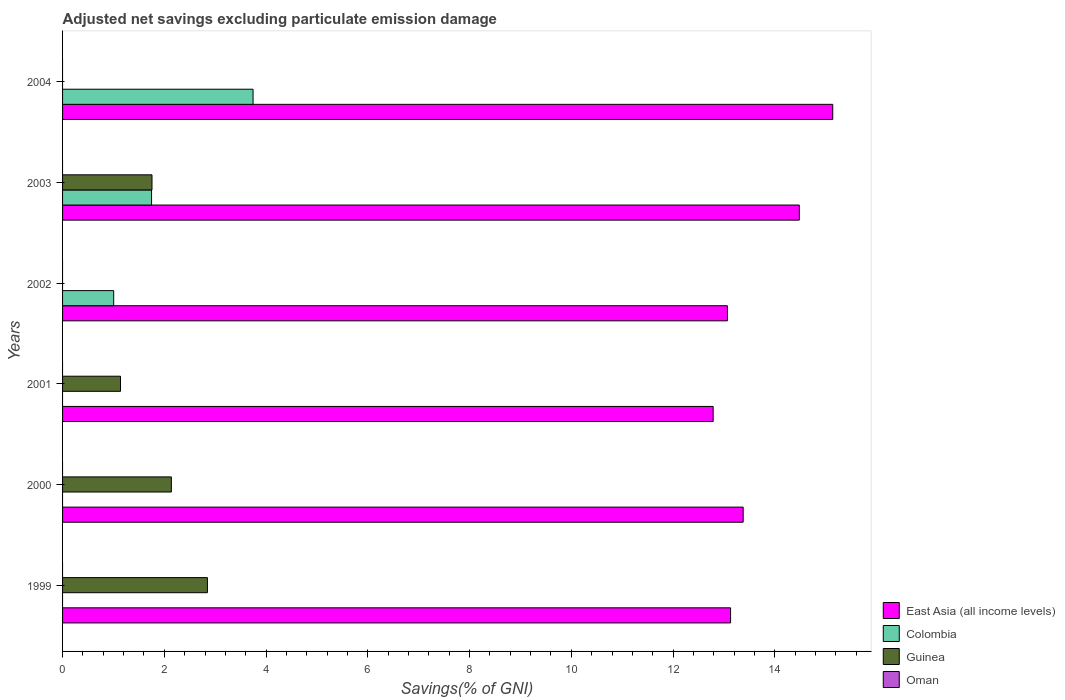Are the number of bars on each tick of the Y-axis equal?
Provide a succinct answer. No. How many bars are there on the 2nd tick from the bottom?
Your answer should be compact. 2. What is the label of the 6th group of bars from the top?
Your answer should be compact. 1999. Across all years, what is the maximum adjusted net savings in East Asia (all income levels)?
Ensure brevity in your answer.  15.14. Across all years, what is the minimum adjusted net savings in East Asia (all income levels)?
Your answer should be compact. 12.79. In which year was the adjusted net savings in East Asia (all income levels) maximum?
Provide a short and direct response. 2004. What is the total adjusted net savings in East Asia (all income levels) in the graph?
Ensure brevity in your answer.  81.98. What is the difference between the adjusted net savings in East Asia (all income levels) in 2001 and that in 2003?
Make the answer very short. -1.69. What is the difference between the adjusted net savings in East Asia (all income levels) in 2003 and the adjusted net savings in Colombia in 2002?
Offer a very short reply. 13.48. What is the average adjusted net savings in East Asia (all income levels) per year?
Offer a very short reply. 13.66. In the year 2000, what is the difference between the adjusted net savings in East Asia (all income levels) and adjusted net savings in Guinea?
Your answer should be very brief. 11.24. In how many years, is the adjusted net savings in Oman greater than 4.8 %?
Your answer should be very brief. 0. What is the ratio of the adjusted net savings in Guinea in 2001 to that in 2003?
Make the answer very short. 0.65. Is the adjusted net savings in Guinea in 1999 less than that in 2000?
Your answer should be very brief. No. What is the difference between the highest and the second highest adjusted net savings in Colombia?
Offer a very short reply. 2. What is the difference between the highest and the lowest adjusted net savings in Guinea?
Provide a short and direct response. 2.85. Are all the bars in the graph horizontal?
Ensure brevity in your answer.  Yes. How many years are there in the graph?
Offer a terse response. 6. Are the values on the major ticks of X-axis written in scientific E-notation?
Keep it short and to the point. No. Does the graph contain grids?
Offer a terse response. No. Where does the legend appear in the graph?
Provide a succinct answer. Bottom right. How many legend labels are there?
Your response must be concise. 4. What is the title of the graph?
Make the answer very short. Adjusted net savings excluding particulate emission damage. Does "Guam" appear as one of the legend labels in the graph?
Give a very brief answer. No. What is the label or title of the X-axis?
Your answer should be compact. Savings(% of GNI). What is the label or title of the Y-axis?
Ensure brevity in your answer.  Years. What is the Savings(% of GNI) of East Asia (all income levels) in 1999?
Offer a terse response. 13.13. What is the Savings(% of GNI) of Guinea in 1999?
Provide a short and direct response. 2.85. What is the Savings(% of GNI) of East Asia (all income levels) in 2000?
Your answer should be very brief. 13.38. What is the Savings(% of GNI) in Guinea in 2000?
Provide a succinct answer. 2.14. What is the Savings(% of GNI) in East Asia (all income levels) in 2001?
Provide a succinct answer. 12.79. What is the Savings(% of GNI) of Colombia in 2001?
Your answer should be very brief. 0. What is the Savings(% of GNI) of Guinea in 2001?
Your answer should be very brief. 1.14. What is the Savings(% of GNI) in East Asia (all income levels) in 2002?
Give a very brief answer. 13.07. What is the Savings(% of GNI) of Colombia in 2002?
Give a very brief answer. 1. What is the Savings(% of GNI) of Guinea in 2002?
Make the answer very short. 0. What is the Savings(% of GNI) of East Asia (all income levels) in 2003?
Provide a succinct answer. 14.48. What is the Savings(% of GNI) of Colombia in 2003?
Provide a short and direct response. 1.75. What is the Savings(% of GNI) of Guinea in 2003?
Ensure brevity in your answer.  1.76. What is the Savings(% of GNI) in East Asia (all income levels) in 2004?
Your answer should be very brief. 15.14. What is the Savings(% of GNI) of Colombia in 2004?
Provide a short and direct response. 3.74. Across all years, what is the maximum Savings(% of GNI) in East Asia (all income levels)?
Offer a very short reply. 15.14. Across all years, what is the maximum Savings(% of GNI) of Colombia?
Keep it short and to the point. 3.74. Across all years, what is the maximum Savings(% of GNI) of Guinea?
Make the answer very short. 2.85. Across all years, what is the minimum Savings(% of GNI) of East Asia (all income levels)?
Provide a succinct answer. 12.79. What is the total Savings(% of GNI) in East Asia (all income levels) in the graph?
Your response must be concise. 81.98. What is the total Savings(% of GNI) of Colombia in the graph?
Your answer should be compact. 6.5. What is the total Savings(% of GNI) in Guinea in the graph?
Give a very brief answer. 7.88. What is the total Savings(% of GNI) in Oman in the graph?
Make the answer very short. 0. What is the difference between the Savings(% of GNI) of East Asia (all income levels) in 1999 and that in 2000?
Keep it short and to the point. -0.25. What is the difference between the Savings(% of GNI) of Guinea in 1999 and that in 2000?
Ensure brevity in your answer.  0.71. What is the difference between the Savings(% of GNI) of East Asia (all income levels) in 1999 and that in 2001?
Give a very brief answer. 0.34. What is the difference between the Savings(% of GNI) in Guinea in 1999 and that in 2001?
Give a very brief answer. 1.71. What is the difference between the Savings(% of GNI) in East Asia (all income levels) in 1999 and that in 2002?
Provide a short and direct response. 0.06. What is the difference between the Savings(% of GNI) of East Asia (all income levels) in 1999 and that in 2003?
Your answer should be very brief. -1.35. What is the difference between the Savings(% of GNI) of Guinea in 1999 and that in 2003?
Keep it short and to the point. 1.09. What is the difference between the Savings(% of GNI) of East Asia (all income levels) in 1999 and that in 2004?
Provide a succinct answer. -2.01. What is the difference between the Savings(% of GNI) in East Asia (all income levels) in 2000 and that in 2001?
Your response must be concise. 0.59. What is the difference between the Savings(% of GNI) in East Asia (all income levels) in 2000 and that in 2002?
Ensure brevity in your answer.  0.31. What is the difference between the Savings(% of GNI) in East Asia (all income levels) in 2000 and that in 2003?
Provide a succinct answer. -1.1. What is the difference between the Savings(% of GNI) in Guinea in 2000 and that in 2003?
Your response must be concise. 0.38. What is the difference between the Savings(% of GNI) in East Asia (all income levels) in 2000 and that in 2004?
Give a very brief answer. -1.76. What is the difference between the Savings(% of GNI) in East Asia (all income levels) in 2001 and that in 2002?
Offer a terse response. -0.28. What is the difference between the Savings(% of GNI) of East Asia (all income levels) in 2001 and that in 2003?
Give a very brief answer. -1.69. What is the difference between the Savings(% of GNI) of Guinea in 2001 and that in 2003?
Ensure brevity in your answer.  -0.62. What is the difference between the Savings(% of GNI) of East Asia (all income levels) in 2001 and that in 2004?
Your answer should be compact. -2.35. What is the difference between the Savings(% of GNI) of East Asia (all income levels) in 2002 and that in 2003?
Offer a very short reply. -1.41. What is the difference between the Savings(% of GNI) in Colombia in 2002 and that in 2003?
Provide a succinct answer. -0.74. What is the difference between the Savings(% of GNI) in East Asia (all income levels) in 2002 and that in 2004?
Give a very brief answer. -2.07. What is the difference between the Savings(% of GNI) of Colombia in 2002 and that in 2004?
Your answer should be very brief. -2.74. What is the difference between the Savings(% of GNI) in East Asia (all income levels) in 2003 and that in 2004?
Make the answer very short. -0.66. What is the difference between the Savings(% of GNI) of Colombia in 2003 and that in 2004?
Offer a very short reply. -2. What is the difference between the Savings(% of GNI) of East Asia (all income levels) in 1999 and the Savings(% of GNI) of Guinea in 2000?
Keep it short and to the point. 10.99. What is the difference between the Savings(% of GNI) in East Asia (all income levels) in 1999 and the Savings(% of GNI) in Guinea in 2001?
Your answer should be compact. 11.99. What is the difference between the Savings(% of GNI) of East Asia (all income levels) in 1999 and the Savings(% of GNI) of Colombia in 2002?
Offer a very short reply. 12.13. What is the difference between the Savings(% of GNI) of East Asia (all income levels) in 1999 and the Savings(% of GNI) of Colombia in 2003?
Provide a succinct answer. 11.38. What is the difference between the Savings(% of GNI) of East Asia (all income levels) in 1999 and the Savings(% of GNI) of Guinea in 2003?
Give a very brief answer. 11.37. What is the difference between the Savings(% of GNI) in East Asia (all income levels) in 1999 and the Savings(% of GNI) in Colombia in 2004?
Make the answer very short. 9.39. What is the difference between the Savings(% of GNI) of East Asia (all income levels) in 2000 and the Savings(% of GNI) of Guinea in 2001?
Give a very brief answer. 12.24. What is the difference between the Savings(% of GNI) in East Asia (all income levels) in 2000 and the Savings(% of GNI) in Colombia in 2002?
Give a very brief answer. 12.37. What is the difference between the Savings(% of GNI) of East Asia (all income levels) in 2000 and the Savings(% of GNI) of Colombia in 2003?
Your answer should be very brief. 11.63. What is the difference between the Savings(% of GNI) in East Asia (all income levels) in 2000 and the Savings(% of GNI) in Guinea in 2003?
Provide a short and direct response. 11.62. What is the difference between the Savings(% of GNI) in East Asia (all income levels) in 2000 and the Savings(% of GNI) in Colombia in 2004?
Make the answer very short. 9.63. What is the difference between the Savings(% of GNI) in East Asia (all income levels) in 2001 and the Savings(% of GNI) in Colombia in 2002?
Offer a very short reply. 11.78. What is the difference between the Savings(% of GNI) of East Asia (all income levels) in 2001 and the Savings(% of GNI) of Colombia in 2003?
Provide a succinct answer. 11.04. What is the difference between the Savings(% of GNI) in East Asia (all income levels) in 2001 and the Savings(% of GNI) in Guinea in 2003?
Make the answer very short. 11.03. What is the difference between the Savings(% of GNI) in East Asia (all income levels) in 2001 and the Savings(% of GNI) in Colombia in 2004?
Your response must be concise. 9.04. What is the difference between the Savings(% of GNI) of East Asia (all income levels) in 2002 and the Savings(% of GNI) of Colombia in 2003?
Your answer should be compact. 11.32. What is the difference between the Savings(% of GNI) of East Asia (all income levels) in 2002 and the Savings(% of GNI) of Guinea in 2003?
Your answer should be compact. 11.31. What is the difference between the Savings(% of GNI) of Colombia in 2002 and the Savings(% of GNI) of Guinea in 2003?
Give a very brief answer. -0.75. What is the difference between the Savings(% of GNI) of East Asia (all income levels) in 2002 and the Savings(% of GNI) of Colombia in 2004?
Offer a terse response. 9.32. What is the difference between the Savings(% of GNI) in East Asia (all income levels) in 2003 and the Savings(% of GNI) in Colombia in 2004?
Your answer should be compact. 10.74. What is the average Savings(% of GNI) in East Asia (all income levels) per year?
Give a very brief answer. 13.66. What is the average Savings(% of GNI) in Colombia per year?
Give a very brief answer. 1.08. What is the average Savings(% of GNI) in Guinea per year?
Give a very brief answer. 1.31. In the year 1999, what is the difference between the Savings(% of GNI) of East Asia (all income levels) and Savings(% of GNI) of Guinea?
Provide a short and direct response. 10.28. In the year 2000, what is the difference between the Savings(% of GNI) of East Asia (all income levels) and Savings(% of GNI) of Guinea?
Your response must be concise. 11.24. In the year 2001, what is the difference between the Savings(% of GNI) of East Asia (all income levels) and Savings(% of GNI) of Guinea?
Ensure brevity in your answer.  11.65. In the year 2002, what is the difference between the Savings(% of GNI) in East Asia (all income levels) and Savings(% of GNI) in Colombia?
Keep it short and to the point. 12.06. In the year 2003, what is the difference between the Savings(% of GNI) of East Asia (all income levels) and Savings(% of GNI) of Colombia?
Provide a succinct answer. 12.73. In the year 2003, what is the difference between the Savings(% of GNI) in East Asia (all income levels) and Savings(% of GNI) in Guinea?
Your answer should be very brief. 12.72. In the year 2003, what is the difference between the Savings(% of GNI) of Colombia and Savings(% of GNI) of Guinea?
Offer a very short reply. -0.01. In the year 2004, what is the difference between the Savings(% of GNI) of East Asia (all income levels) and Savings(% of GNI) of Colombia?
Keep it short and to the point. 11.39. What is the ratio of the Savings(% of GNI) in East Asia (all income levels) in 1999 to that in 2000?
Provide a succinct answer. 0.98. What is the ratio of the Savings(% of GNI) of Guinea in 1999 to that in 2000?
Your answer should be very brief. 1.33. What is the ratio of the Savings(% of GNI) of East Asia (all income levels) in 1999 to that in 2001?
Provide a succinct answer. 1.03. What is the ratio of the Savings(% of GNI) of Guinea in 1999 to that in 2001?
Offer a very short reply. 2.5. What is the ratio of the Savings(% of GNI) of East Asia (all income levels) in 1999 to that in 2002?
Your answer should be compact. 1. What is the ratio of the Savings(% of GNI) in East Asia (all income levels) in 1999 to that in 2003?
Provide a succinct answer. 0.91. What is the ratio of the Savings(% of GNI) in Guinea in 1999 to that in 2003?
Your answer should be compact. 1.62. What is the ratio of the Savings(% of GNI) of East Asia (all income levels) in 1999 to that in 2004?
Provide a succinct answer. 0.87. What is the ratio of the Savings(% of GNI) in East Asia (all income levels) in 2000 to that in 2001?
Provide a short and direct response. 1.05. What is the ratio of the Savings(% of GNI) in Guinea in 2000 to that in 2001?
Make the answer very short. 1.88. What is the ratio of the Savings(% of GNI) in East Asia (all income levels) in 2000 to that in 2002?
Keep it short and to the point. 1.02. What is the ratio of the Savings(% of GNI) of East Asia (all income levels) in 2000 to that in 2003?
Ensure brevity in your answer.  0.92. What is the ratio of the Savings(% of GNI) of Guinea in 2000 to that in 2003?
Make the answer very short. 1.22. What is the ratio of the Savings(% of GNI) in East Asia (all income levels) in 2000 to that in 2004?
Provide a succinct answer. 0.88. What is the ratio of the Savings(% of GNI) of East Asia (all income levels) in 2001 to that in 2002?
Your response must be concise. 0.98. What is the ratio of the Savings(% of GNI) in East Asia (all income levels) in 2001 to that in 2003?
Ensure brevity in your answer.  0.88. What is the ratio of the Savings(% of GNI) in Guinea in 2001 to that in 2003?
Offer a very short reply. 0.65. What is the ratio of the Savings(% of GNI) of East Asia (all income levels) in 2001 to that in 2004?
Offer a terse response. 0.84. What is the ratio of the Savings(% of GNI) of East Asia (all income levels) in 2002 to that in 2003?
Your answer should be very brief. 0.9. What is the ratio of the Savings(% of GNI) of Colombia in 2002 to that in 2003?
Offer a very short reply. 0.57. What is the ratio of the Savings(% of GNI) of East Asia (all income levels) in 2002 to that in 2004?
Your answer should be compact. 0.86. What is the ratio of the Savings(% of GNI) of Colombia in 2002 to that in 2004?
Provide a short and direct response. 0.27. What is the ratio of the Savings(% of GNI) in East Asia (all income levels) in 2003 to that in 2004?
Make the answer very short. 0.96. What is the ratio of the Savings(% of GNI) in Colombia in 2003 to that in 2004?
Your response must be concise. 0.47. What is the difference between the highest and the second highest Savings(% of GNI) in East Asia (all income levels)?
Your answer should be compact. 0.66. What is the difference between the highest and the second highest Savings(% of GNI) in Colombia?
Offer a very short reply. 2. What is the difference between the highest and the second highest Savings(% of GNI) of Guinea?
Your answer should be very brief. 0.71. What is the difference between the highest and the lowest Savings(% of GNI) of East Asia (all income levels)?
Provide a short and direct response. 2.35. What is the difference between the highest and the lowest Savings(% of GNI) in Colombia?
Ensure brevity in your answer.  3.74. What is the difference between the highest and the lowest Savings(% of GNI) of Guinea?
Your answer should be compact. 2.85. 